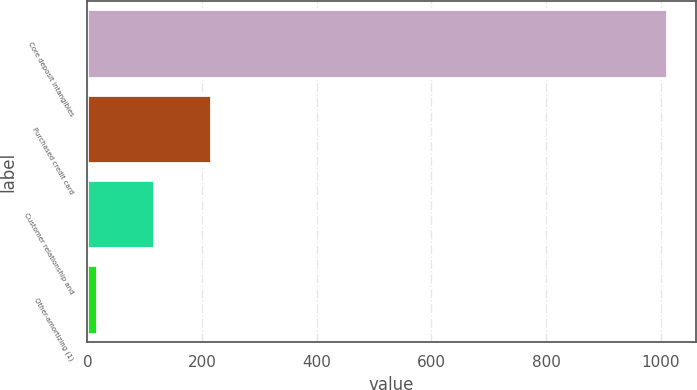Convert chart. <chart><loc_0><loc_0><loc_500><loc_500><bar_chart><fcel>Core deposit intangibles<fcel>Purchased credit card<fcel>Customer relationship and<fcel>Other-amortizing (1)<nl><fcel>1011<fcel>215<fcel>115.5<fcel>16<nl></chart> 